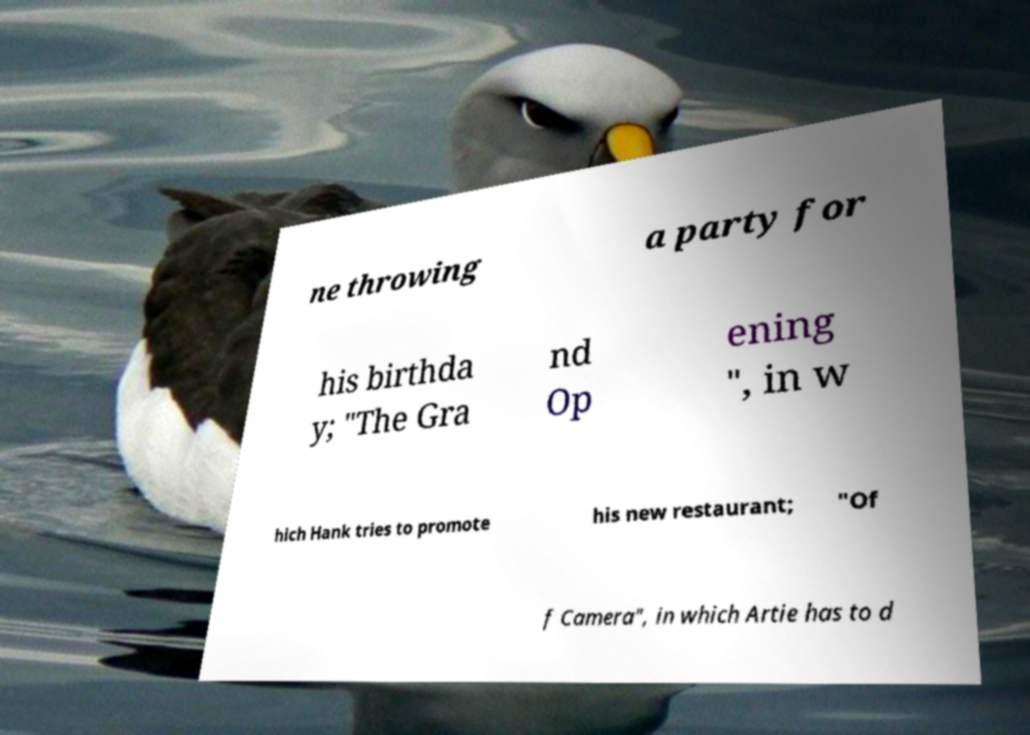I need the written content from this picture converted into text. Can you do that? ne throwing a party for his birthda y; "The Gra nd Op ening ", in w hich Hank tries to promote his new restaurant; "Of f Camera", in which Artie has to d 